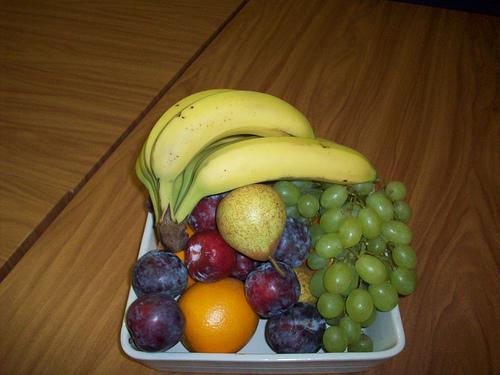How many bananas are in the basket?
Short answer required. 6. What is your favorite produce item shown?
Concise answer only. Banana. How many pears are in front of the banana?
Keep it brief. 1. How many different types of fruit are present?
Answer briefly. 5. Are these bananas in a bunch or singles?
Concise answer only. Bunch. What is the picture capturing?
Give a very brief answer. Fruit. What is the probability that a pear will be randomly selected from this plate?
Write a very short answer. Not very likely. What part of the fruit pictured was thrown out?
Short answer required. Grapes. What is in the blue bowl?
Concise answer only. Fruit. What colors are the fruits?
Be succinct. Yellow green and purple. How many different types of fruits and vegetables here?
Write a very short answer. 5. How many pictures of apples are there in this scene?
Keep it brief. 0. What is the pear made to look like?
Concise answer only. Apple. Which fruit is by  the orange?
Write a very short answer. Plums. What fruit is this?
Concise answer only. Banana, grape, apple, orange. Is there a way to know the company who processed the banana?
Write a very short answer. No. What is the green items?
Keep it brief. Grapes. Can you give count the amount of bananas?
Quick response, please. 7. How many banana dolphins are there?
Concise answer only. 0. What type of fruit is in the bowl?
Give a very brief answer. Bananas. What expression is the banana making?
Answer briefly. Frown. Are the vegetables whole?
Answer briefly. Yes. 